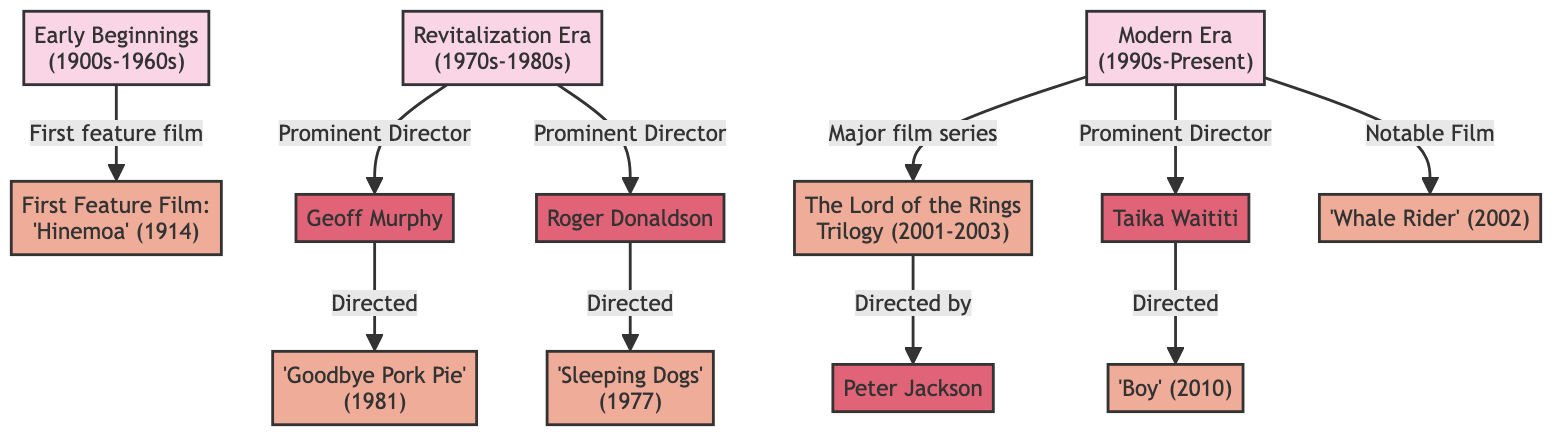What is the first feature film mentioned in the diagram? The diagram identifies 'Hinemoa' as the first feature film, linked to the "Early Beginnings" era (1900s-1960s).
Answer: Hinemoa Which director is associated with 'Goodbye Pork Pie'? The diagram connects 'Goodbye Pork Pie' to the director Geoff Murphy under the "Revitalization Era" (1970s-1980s).
Answer: Geoff Murphy How many prominent directors are listed in the "Modern Era"? The diagram shows two prominent directors in the "Modern Era" (1990s-Present): Peter Jackson and Taika Waititi.
Answer: 2 Who directed 'Whale Rider'? The diagram does not specify a director for 'Whale Rider,' but it is included as a notable film in the "Modern Era." The absence indicates it was not directly linked to a specific director in this context.
Answer: (not specified) What film marks the transition from the "Early Beginnings" to the "Revitalization Era"? The "Early Beginnings" leads to the "Revitalization Era" without a direct film connecting both; instead, it progresses to key directors and films in the revitalization era independent of one another.
Answer: None (direct connection) Which trilogy is highlighted in the "Modern Era"? The diagram emphasizes 'The Lord of the Rings Trilogy' as a major film series within the "Modern Era" (1990s-Present).
Answer: The Lord of the Rings Trilogy What evidence in the diagram points to a resurgence in New Zealand cinema? The linkages of prominent directors (Geoff Murphy and Roger Donaldson) to notable films ('Goodbye Pork Pie' and 'Sleeping Dogs') during the "Revitalization Era" supports this resurgence.
Answer: Geoff Murphy and Roger Donaldson Which film directed by Taika Waititi is listed? The diagram specifically notes 'Boy' as the film directed by Taika Waititi within the "Modern Era" (1990s-Present).
Answer: Boy 